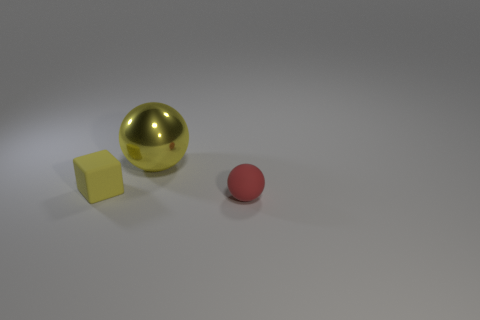Add 1 big things. How many objects exist? 4 Subtract all blocks. How many objects are left? 2 Add 1 tiny things. How many tiny things are left? 3 Add 1 cubes. How many cubes exist? 2 Subtract 0 gray blocks. How many objects are left? 3 Subtract all small rubber blocks. Subtract all tiny blue matte blocks. How many objects are left? 2 